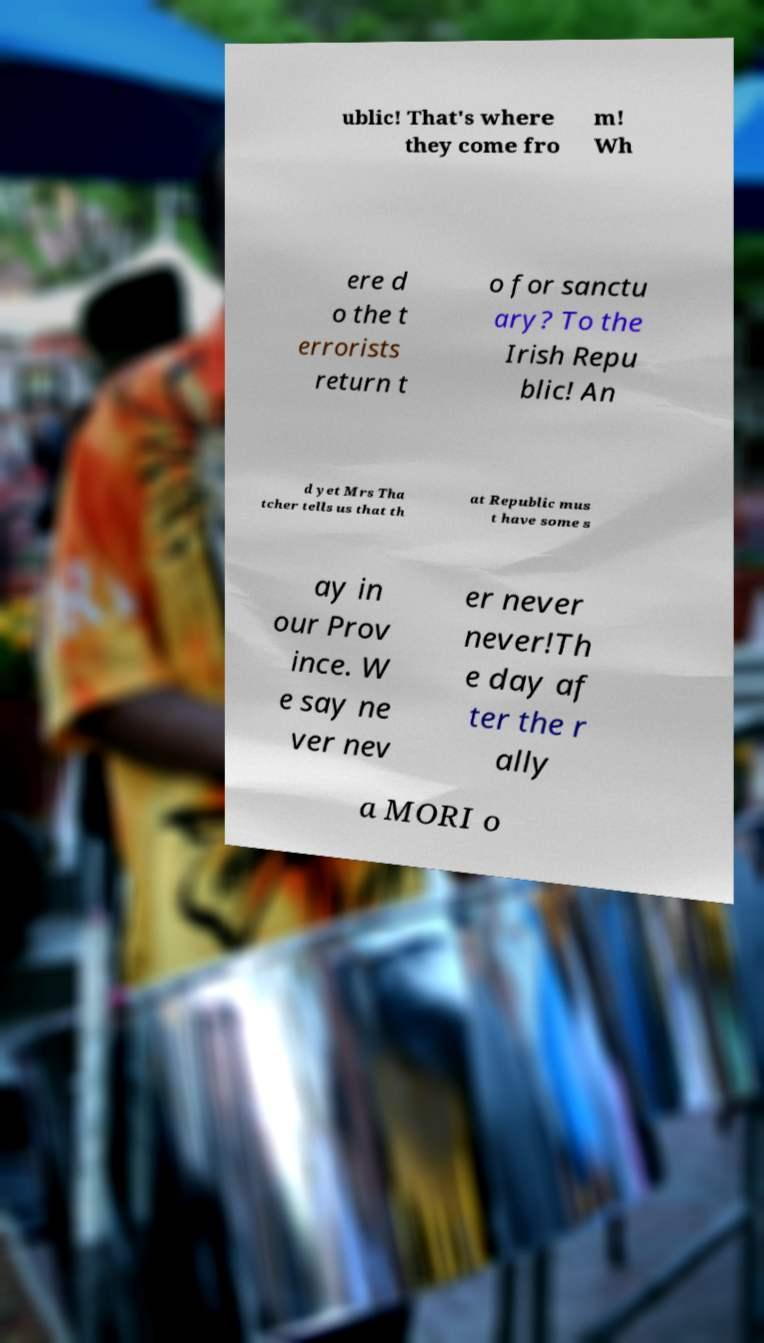Please identify and transcribe the text found in this image. ublic! That's where they come fro m! Wh ere d o the t errorists return t o for sanctu ary? To the Irish Repu blic! An d yet Mrs Tha tcher tells us that th at Republic mus t have some s ay in our Prov ince. W e say ne ver nev er never never!Th e day af ter the r ally a MORI o 